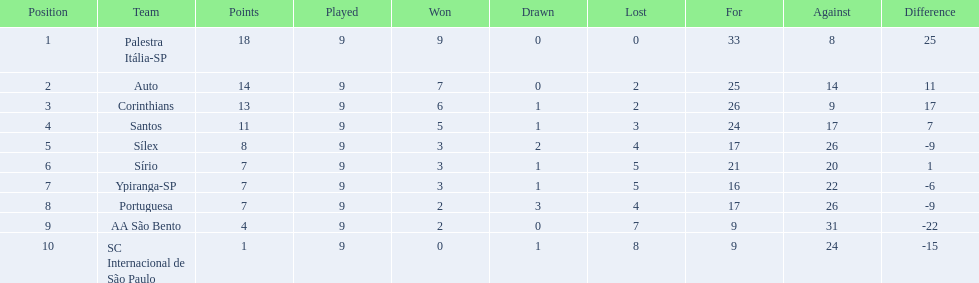What is the count of games played by every team? 9, 9, 9, 9, 9, 9, 9, 9, 9, 9. Is there a team that accumulated 13 points throughout their matches? 13. What is the name of this team? Corinthians. 